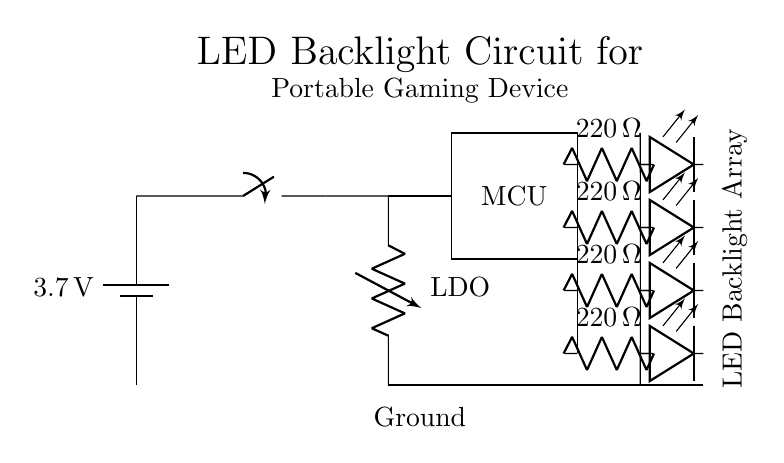What is the voltage of the battery? The battery provides a voltage of 3.7 volts, as indicated by the label on the battery symbol in the circuit diagram.
Answer: 3.7 volts What is the purpose of the voltage regulator? The voltage regulator, labeled as LDO, is used to maintain a stable output voltage for the connected components, ensuring they receive a consistent voltage despite variations in the input voltage from the battery.
Answer: Stabilizing output voltage How many resistors are used in the LED circuit? There are four resistors in the circuit, each connected in series with the LEDs, as shown by the labels next to each resistor in the diagram.
Answer: Four What is the resistance value of each resistor? Each resistor is labeled with a resistance value of 220 Ohms, which is indicated next to each resistor symbol in the circuit diagram.
Answer: 220 Ohms Which component controls the lights in this circuit? The microcontroller (MCU) is responsible for controlling the operation of the LEDs, as it connects to the LED array and manages their on/off states based on programming.
Answer: Microcontroller If the circuit is powered, how many LEDs will be lit? All four LEDs will be lit if the circuit is powered and the switch is closed, as they are connected in parallel with their series resistors which allow current to flow through all of them simultaneously.
Answer: Four LEDs What would happen if one LED fails in this circuit configuration? If one LED fails in this parallel configuration, the remaining LEDs would still light up because they are connected separately with their own resistors, allowing current to pass through the intact LEDs.
Answer: Others remain lit 